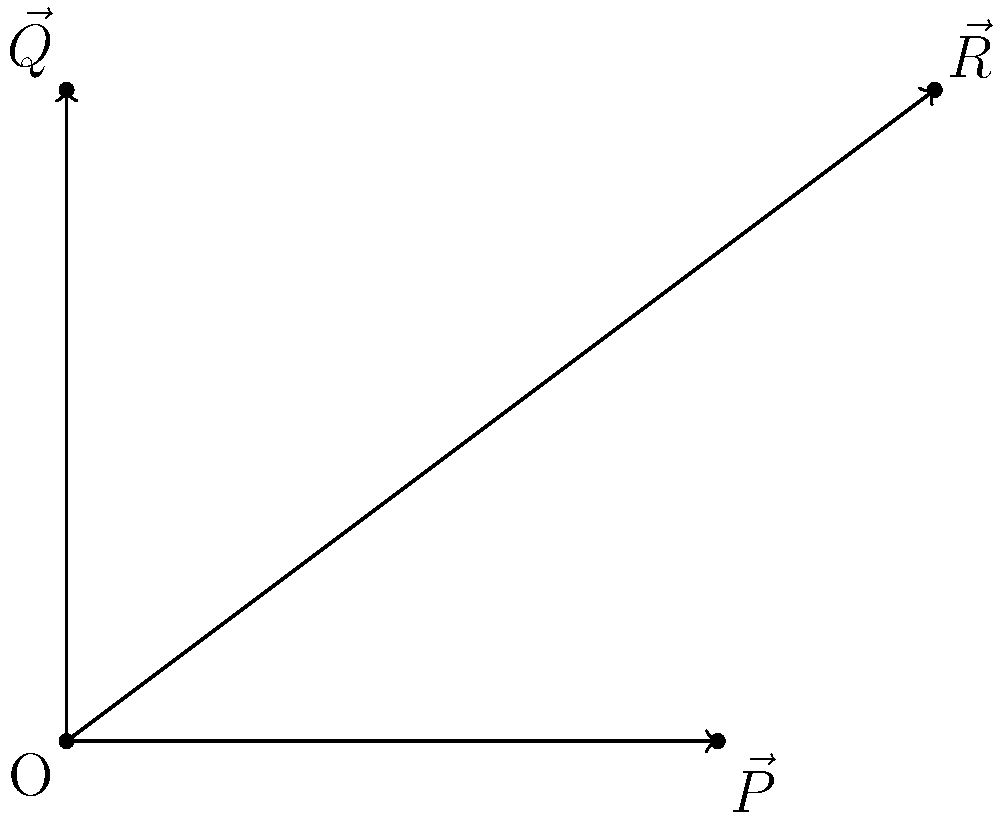As the school principal, you've implemented various health initiatives to improve the overall health of your school. The vector $\vec{R}$ represents the total health improvement, which can be decomposed into two components: $\vec{P}$ for physical health initiatives and $\vec{Q}$ for mental health initiatives. Given that $\vec{R} = 4\hat{i} + 3\hat{j}$, $\vec{P} = 3\hat{i}$, and $\vec{Q} = 3\hat{j}$, calculate the magnitude of the vector representing the combined effect of other health initiatives not accounted for by $\vec{P}$ and $\vec{Q}$. To solve this problem, we'll follow these steps:

1) First, recall that vectors can be added using the parallelogram law. In this case, $\vec{R} = \vec{P} + \vec{Q} + \vec{X}$, where $\vec{X}$ is the vector representing other health initiatives.

2) We're given:
   $\vec{R} = 4\hat{i} + 3\hat{j}$
   $\vec{P} = 3\hat{i}$
   $\vec{Q} = 3\hat{j}$

3) To find $\vec{X}$, we can subtract $\vec{P}$ and $\vec{Q}$ from $\vec{R}$:
   $\vec{X} = \vec{R} - (\vec{P} + \vec{Q})$

4) Let's perform this subtraction:
   $\vec{X} = (4\hat{i} + 3\hat{j}) - (3\hat{i} + 3\hat{j})$
   $\vec{X} = 4\hat{i} + 3\hat{j} - 3\hat{i} - 3\hat{j}$
   $\vec{X} = (4-3)\hat{i} + (3-3)\hat{j}$
   $\vec{X} = 1\hat{i} + 0\hat{j}$
   $\vec{X} = \hat{i}$

5) Now that we have $\vec{X}$, we need to calculate its magnitude. The magnitude of a vector $\vec{a} = a_x\hat{i} + a_y\hat{j}$ is given by $|\vec{a}| = \sqrt{a_x^2 + a_y^2}$.

6) For $\vec{X} = \hat{i}$, we have:
   $|\vec{X}| = \sqrt{1^2 + 0^2} = \sqrt{1} = 1$

Therefore, the magnitude of the vector representing other health initiatives is 1.
Answer: 1 